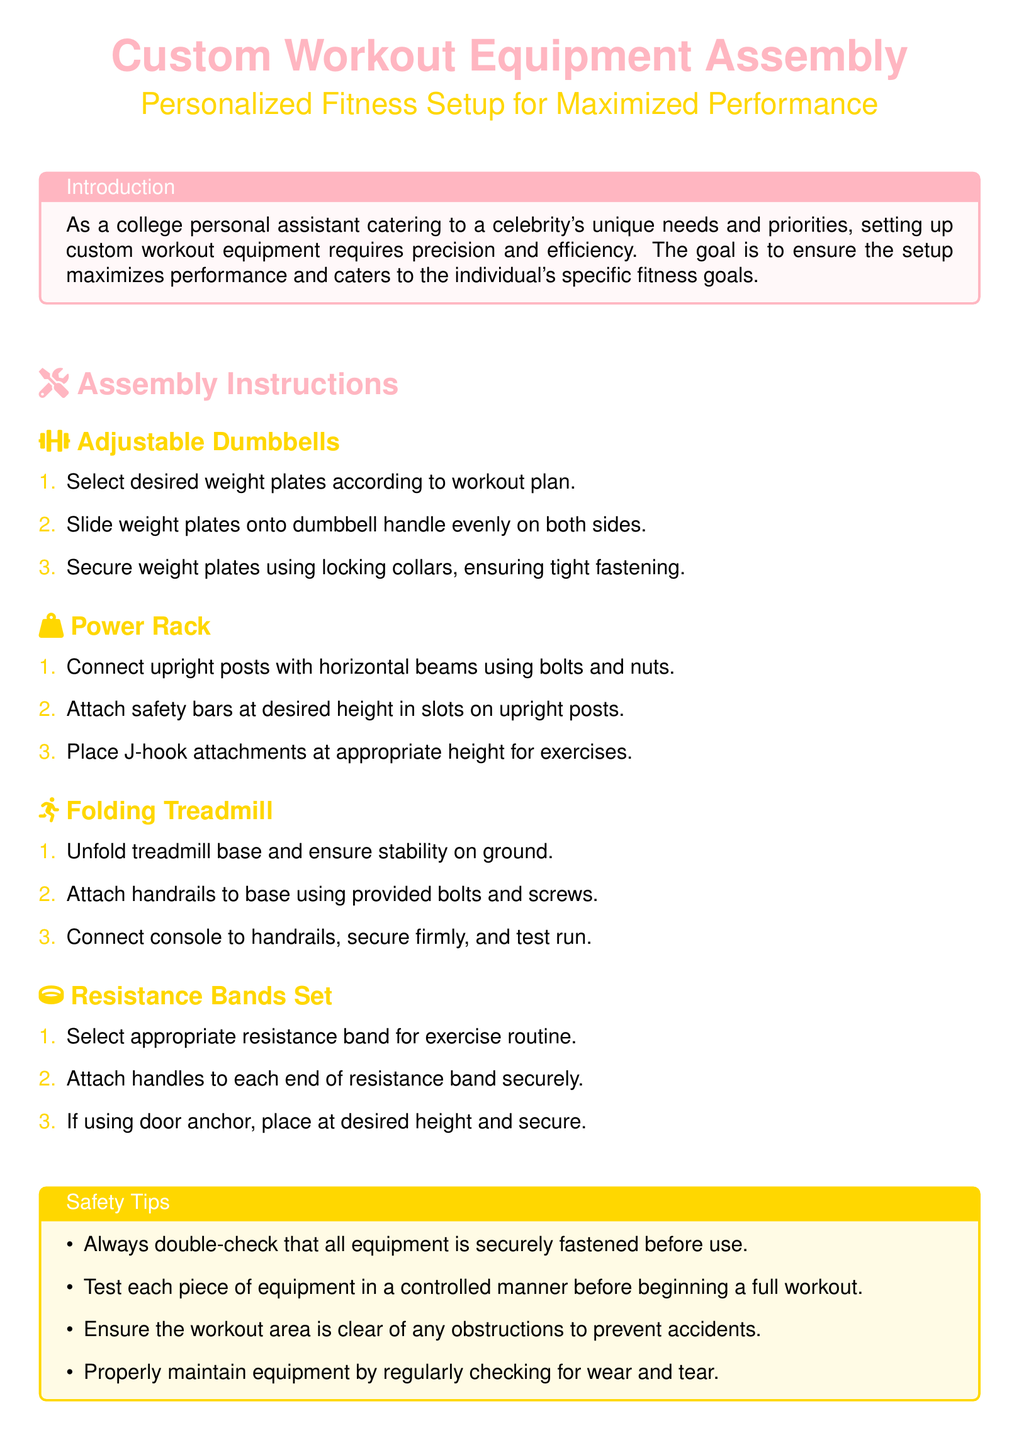What is the purpose of the assembly instructions? The assembly instructions aim to ensure the setup maximizes performance and caters to the individual's specific fitness goals.
Answer: Maximize performance How many steps are required for setting up the adjustable dumbbells? The instructions for adjustable dumbbells include three steps to complete the setup.
Answer: Three steps What color is used for the assembly instruction section title? The section title for assembly instructions is in the color specified as celebrity gold.
Answer: Celebrity gold What is the first step for setting up the folding treadmill? The first step for setting up the folding treadmill is to unfold the treadmill base and ensure stability on the ground.
Answer: Unfold treadmill base How many safety tips are provided in the document? The safety tips section lists four different tips to ensure safe equipment use.
Answer: Four tips What should be ensured before using any equipment? It is advised to double-check that all equipment is securely fastened before use.
Answer: Securely fastened What should you do if using a door anchor with resistance bands? If using a door anchor, you should place it at the desired height and secure it.
Answer: Place at desired height What are the materials used for attaching handrails to the treadmill? Handrails are attached to the treadmill base using provided bolts and screws.
Answer: Bolts and screws 